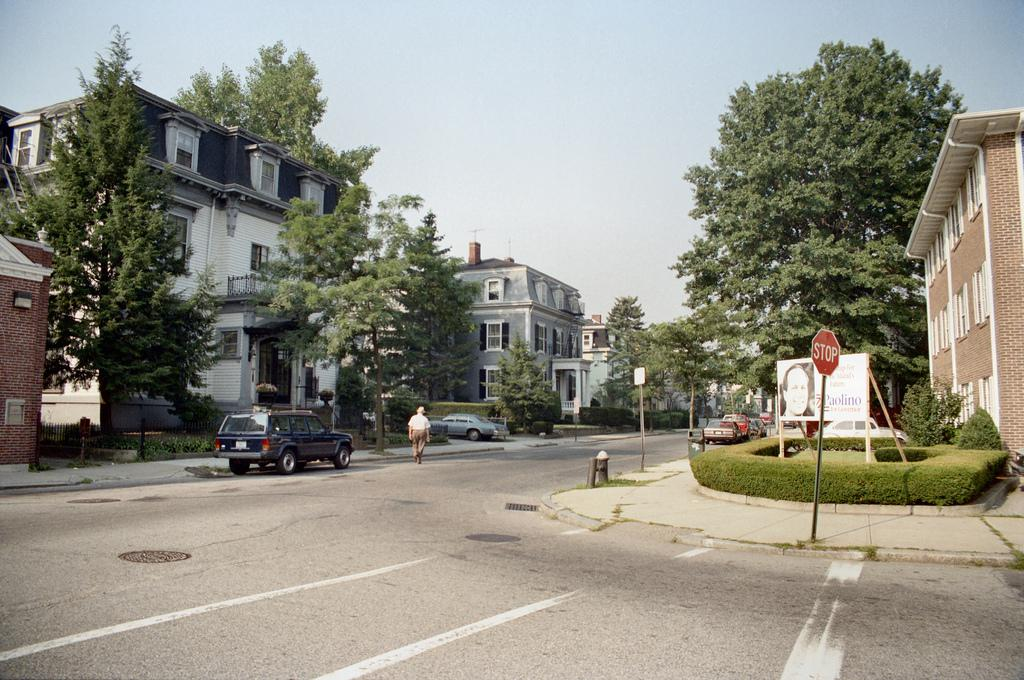Question: what type of lines are on the road?
Choices:
A. Dotted line to divide road.
B. Solid line for edge of road.
C. Crosswalk.
D. Stop at intersection.
Answer with the letter. Answer: C Question: how is the weather?
Choices:
A. A mild day.
B. A cold day.
C. It is a sunny day.
D. A snowy day.
Answer with the letter. Answer: C Question: who is crossing the street?
Choices:
A. A mother.
B. A child.
C. A father.
D. An old man.
Answer with the letter. Answer: D Question: what direction to go after the stop sign?
Choices:
A. Right.
B. Left.
C. Straight.
D. Around the block.
Answer with the letter. Answer: A Question: why is there a crosswalk?
Choices:
A. For pedestrians.
B. For school children.
C. This is downtown.
D. This is a residential district.
Answer with the letter. Answer: A Question: how many levels do the buildings have?
Choices:
A. 12.
B. 13.
C. 3.
D. 5.
Answer with the letter. Answer: C Question: what type of trimmed plants are in the picture?
Choices:
A. Bushes.
B. Bonsai trees.
C. Hedges.
D. Wildflowers.
Answer with the letter. Answer: C Question: what is in the middle of the road?
Choices:
A. A chicken.
B. A turtle.
C. A construction sign.
D. A manhole.
Answer with the letter. Answer: D Question: what type of sign is in the yard?
Choices:
A. A for sale sign.
B. Political.
C. A for rent sign.
D. A welcome sign.
Answer with the letter. Answer: B Question: what lines the streets?
Choices:
A. Cars.
B. Houses.
C. Stores.
D. Tall trees.
Answer with the letter. Answer: D Question: what are on the street?
Choices:
A. White lines.
B. Cars.
C. Trucks.
D. People.
Answer with the letter. Answer: A Question: how is the sky?
Choices:
A. Sunny.
B. Blue.
C. Beautiful.
D. No clouds are there.
Answer with the letter. Answer: D 